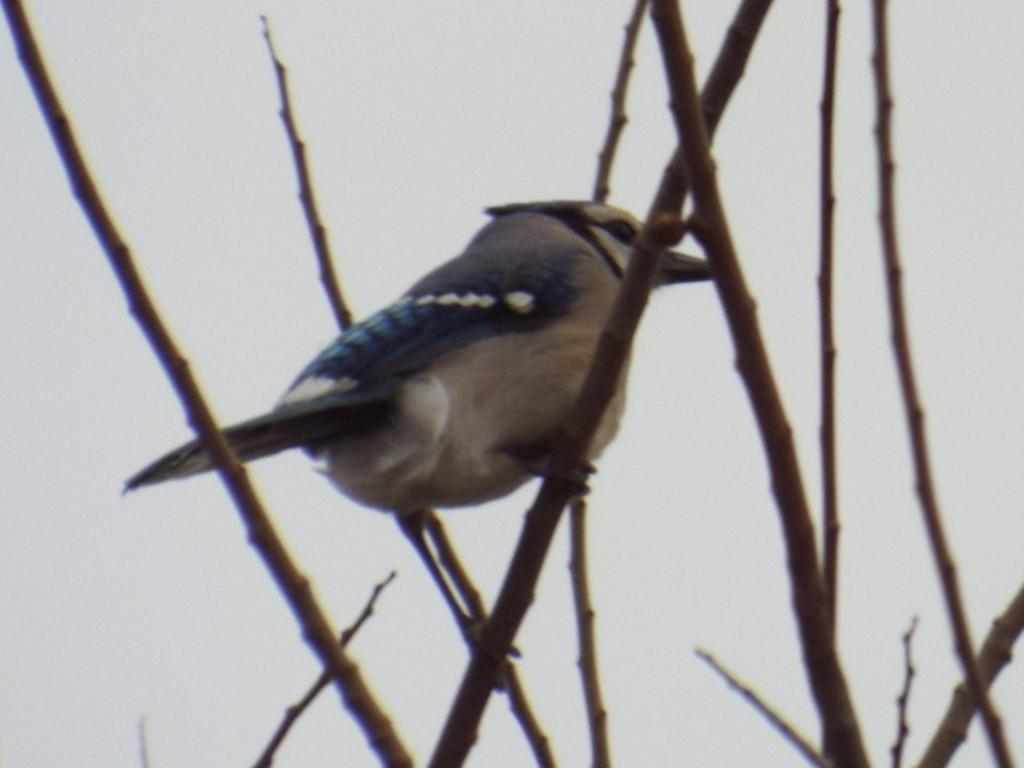What type of animal is in the image? There is a bird in the image. Where is the bird located? The bird is on a stem. What can be seen in the background of the image? There is sky visible in the background of the image. What type of locket is the bird wearing in the image? There is no locket present in the image, as the bird is not wearing any accessories. 